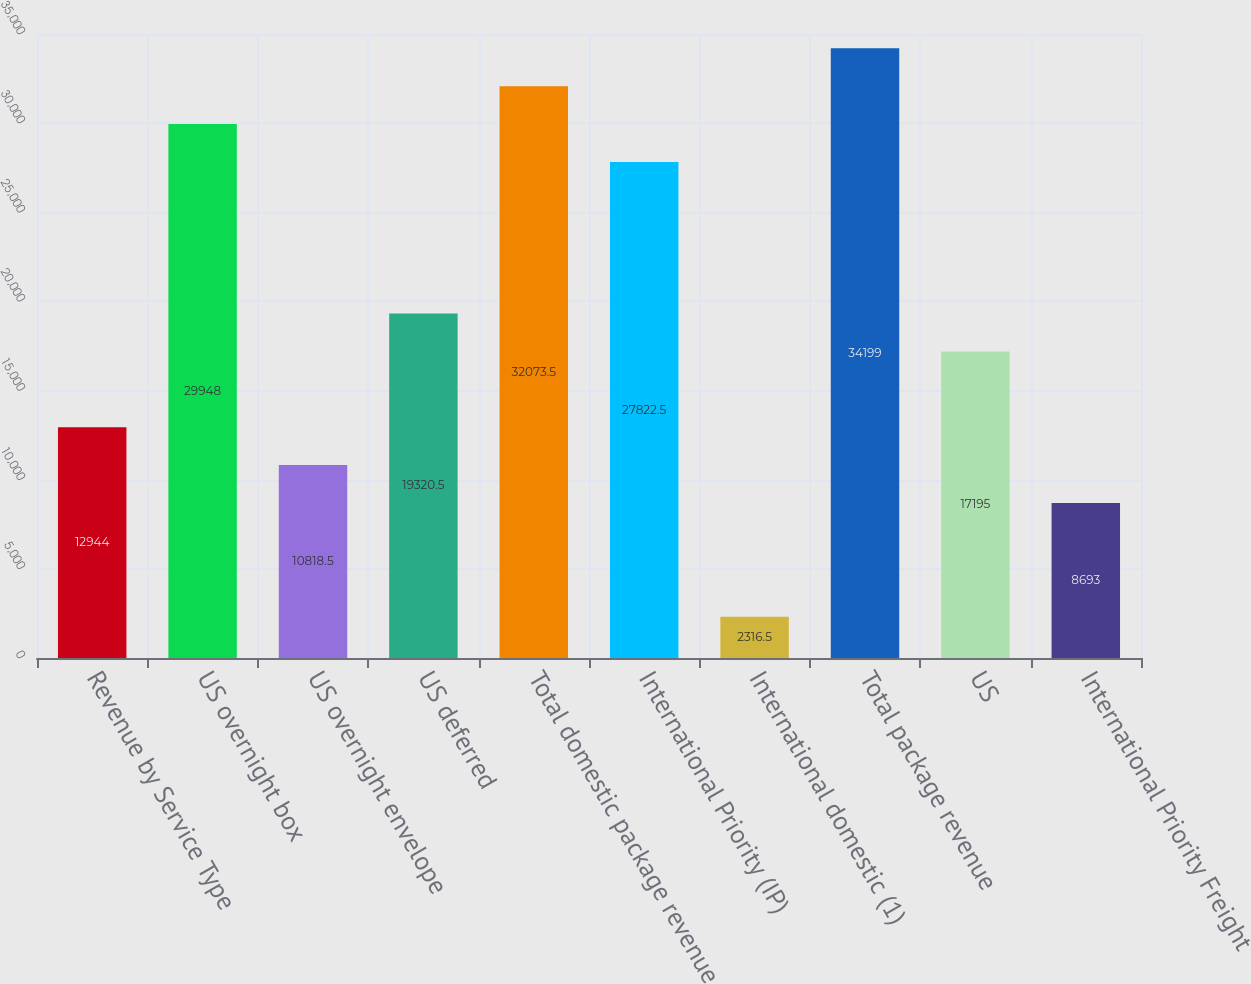<chart> <loc_0><loc_0><loc_500><loc_500><bar_chart><fcel>Revenue by Service Type<fcel>US overnight box<fcel>US overnight envelope<fcel>US deferred<fcel>Total domestic package revenue<fcel>International Priority (IP)<fcel>International domestic (1)<fcel>Total package revenue<fcel>US<fcel>International Priority Freight<nl><fcel>12944<fcel>29948<fcel>10818.5<fcel>19320.5<fcel>32073.5<fcel>27822.5<fcel>2316.5<fcel>34199<fcel>17195<fcel>8693<nl></chart> 